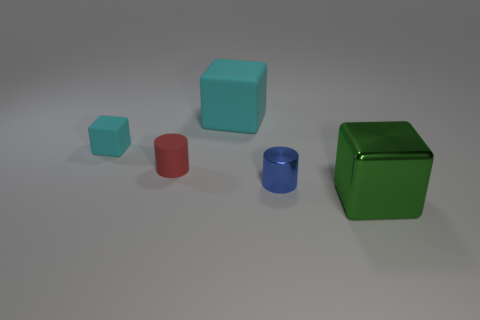How many metal things are tiny blocks or small cylinders?
Give a very brief answer. 1. What number of large matte things are the same color as the tiny metal cylinder?
Provide a succinct answer. 0. What is the material of the cylinder that is on the right side of the red matte cylinder that is to the left of the big block behind the big shiny block?
Give a very brief answer. Metal. There is a tiny cylinder left of the cylinder on the right side of the big cyan thing; what color is it?
Provide a succinct answer. Red. What number of tiny objects are either cyan things or gray matte balls?
Offer a very short reply. 1. How many blue balls are made of the same material as the big cyan thing?
Your response must be concise. 0. What is the size of the metallic object behind the big green thing?
Your answer should be compact. Small. What shape is the metal object that is behind the large cube in front of the blue cylinder?
Keep it short and to the point. Cylinder. How many blocks are right of the large object that is behind the metallic object behind the green shiny thing?
Your response must be concise. 1. Is the number of big matte things that are behind the green metal object less than the number of big green metallic cylinders?
Your response must be concise. No. 